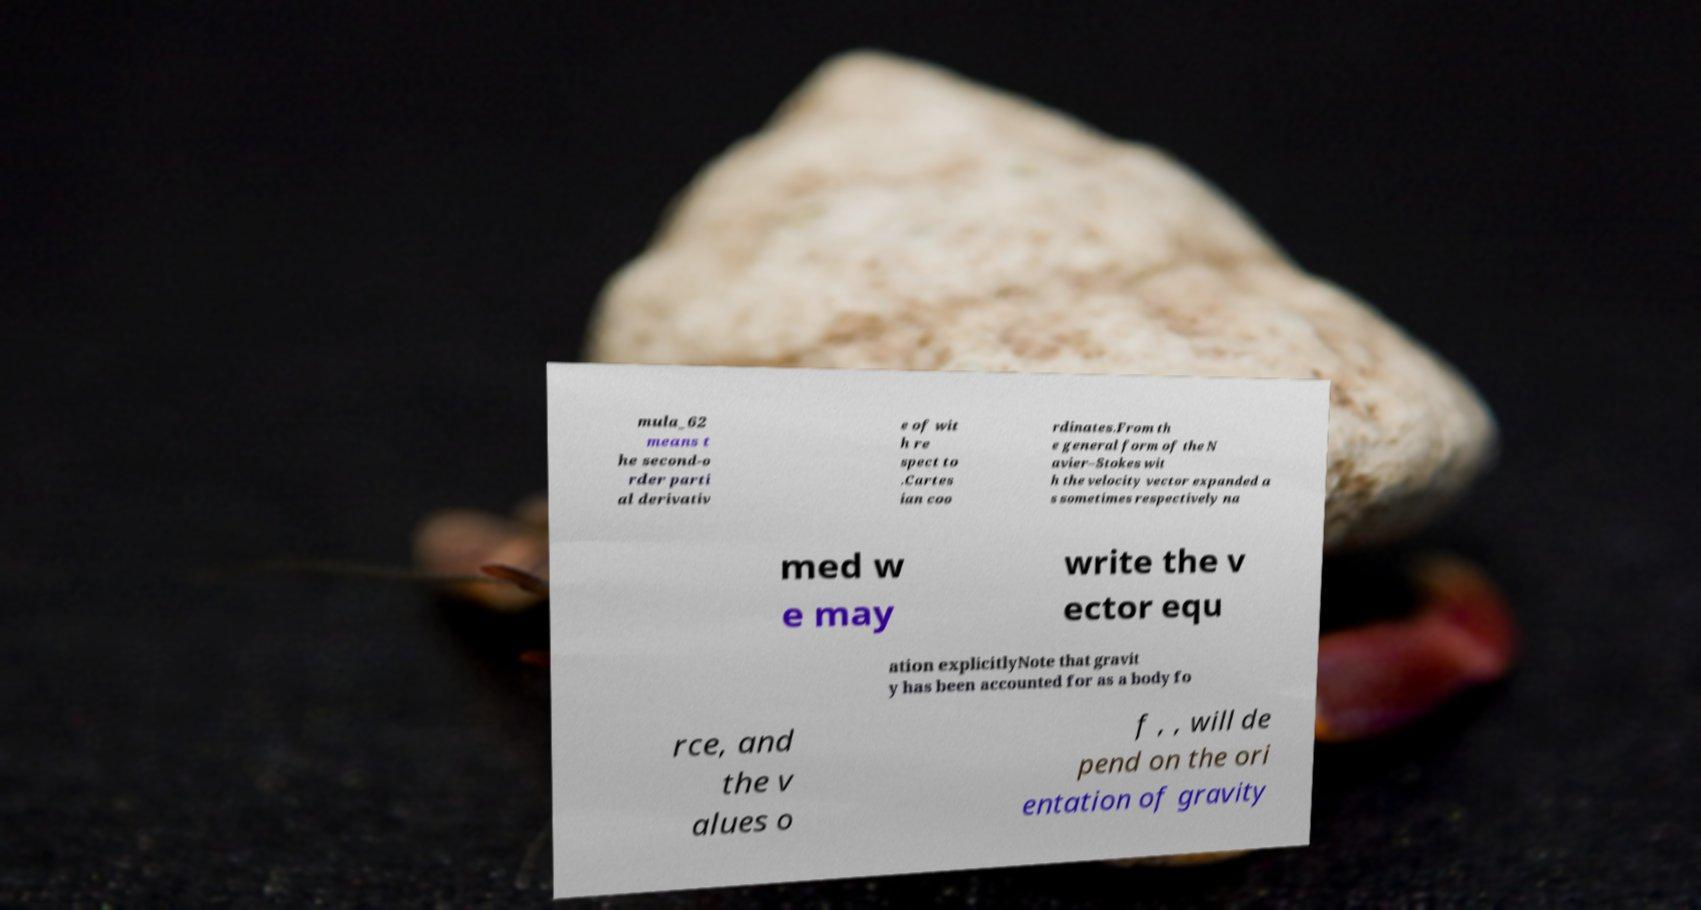Can you accurately transcribe the text from the provided image for me? mula_62 means t he second-o rder parti al derivativ e of wit h re spect to .Cartes ian coo rdinates.From th e general form of the N avier–Stokes wit h the velocity vector expanded a s sometimes respectively na med w e may write the v ector equ ation explicitlyNote that gravit y has been accounted for as a body fo rce, and the v alues o f , , will de pend on the ori entation of gravity 